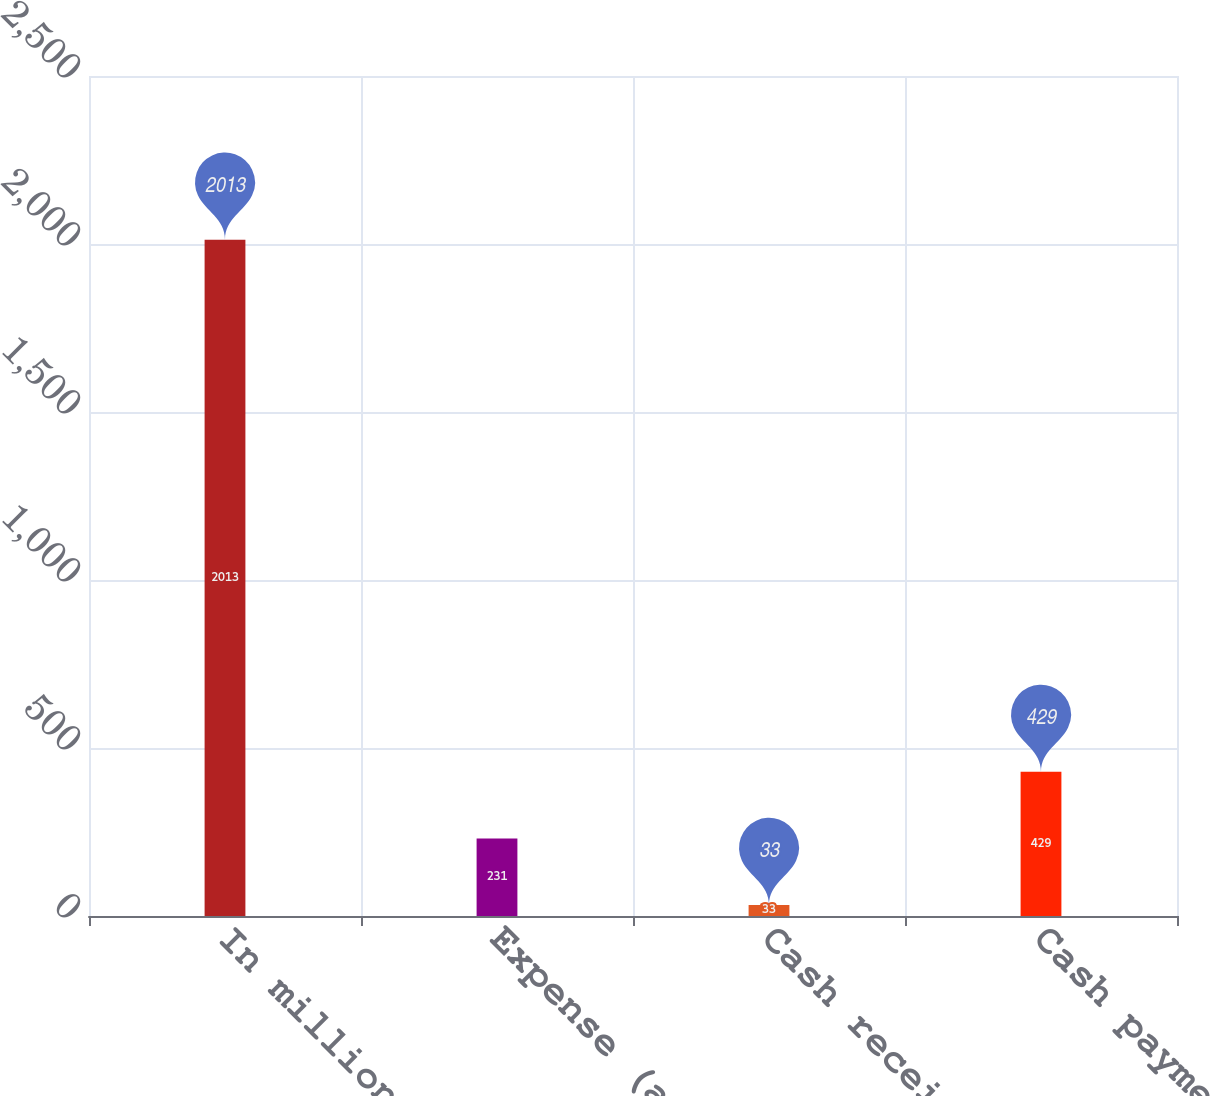Convert chart to OTSL. <chart><loc_0><loc_0><loc_500><loc_500><bar_chart><fcel>In millions<fcel>Expense (a)<fcel>Cash receipts (b)<fcel>Cash payments (c)<nl><fcel>2013<fcel>231<fcel>33<fcel>429<nl></chart> 